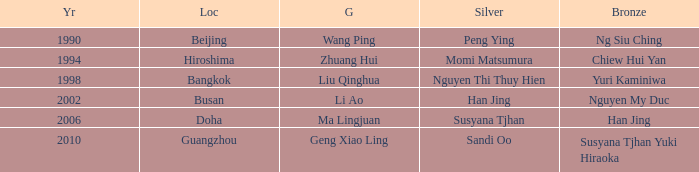What's the lowest Year with the Location of Bangkok? 1998.0. 